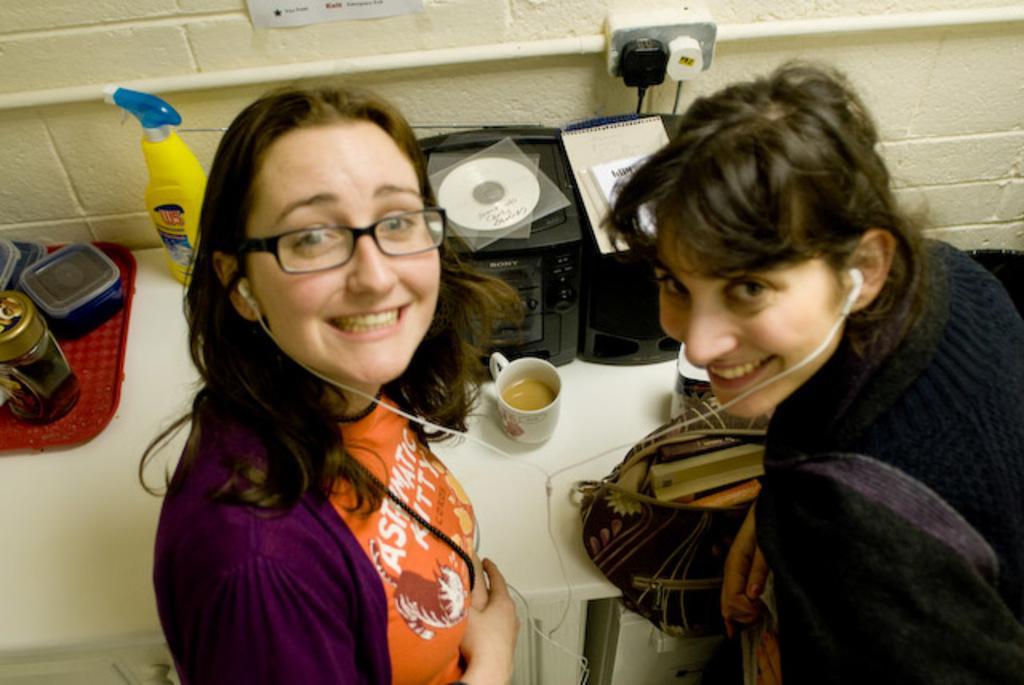Could you give a brief overview of what you see in this image? This image consists of two women wearing jackets. Beside her there is a table in white color on which there is a music player. 